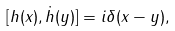<formula> <loc_0><loc_0><loc_500><loc_500>[ h ( x ) , \dot { h } ( y ) ] = i \delta ( x - y ) ,</formula> 